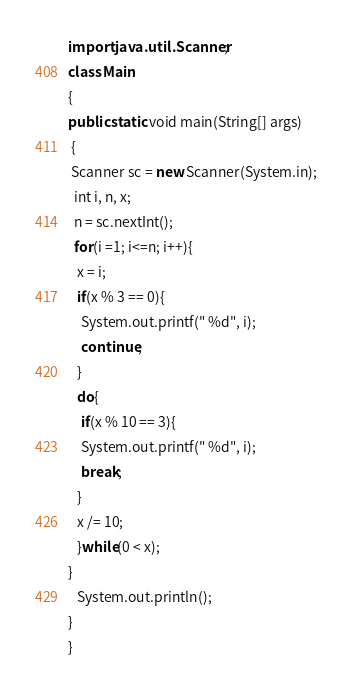<code> <loc_0><loc_0><loc_500><loc_500><_Java_>import java.util.Scanner;
class Main
{
public static void main(String[] args)
 {
 Scanner sc = new Scanner(System.in);
  int i, n, x;
  n = sc.nextInt();     
  for(i =1; i<=n; i++){
   x = i;
   if(x % 3 == 0){
    System.out.printf(" %d", i);
    continue;
   }
   do{
    if(x % 10 == 3){
    System.out.printf(" %d", i);
    break;
   }
   x /= 10;
   }while(0 < x);
}
   System.out.println();
}  
}

</code> 